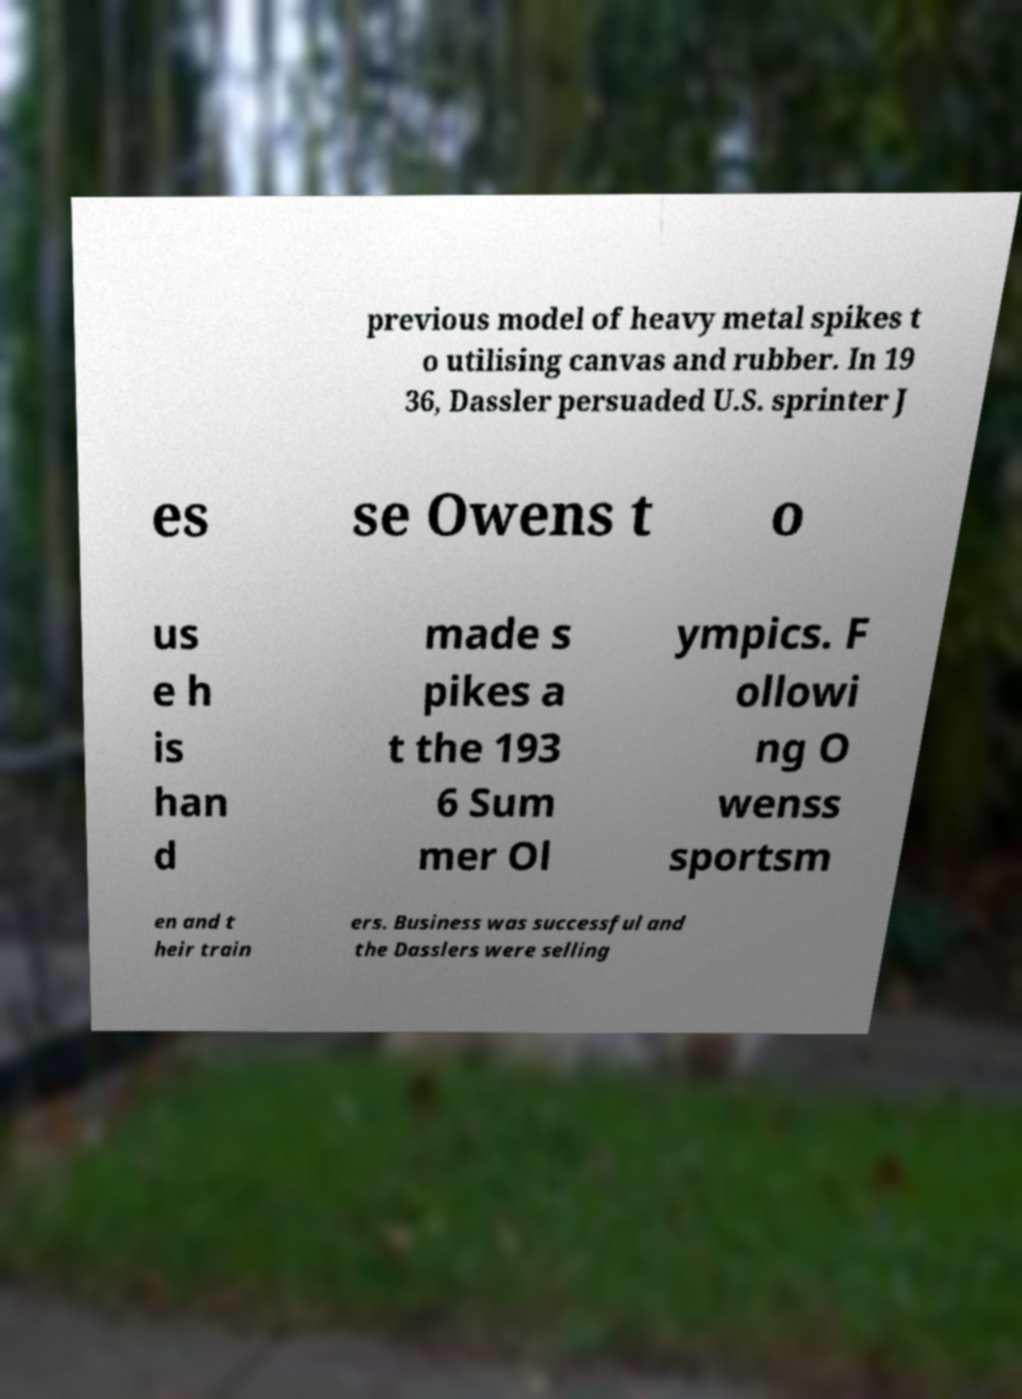Please read and relay the text visible in this image. What does it say? previous model of heavy metal spikes t o utilising canvas and rubber. In 19 36, Dassler persuaded U.S. sprinter J es se Owens t o us e h is han d made s pikes a t the 193 6 Sum mer Ol ympics. F ollowi ng O wenss sportsm en and t heir train ers. Business was successful and the Dasslers were selling 